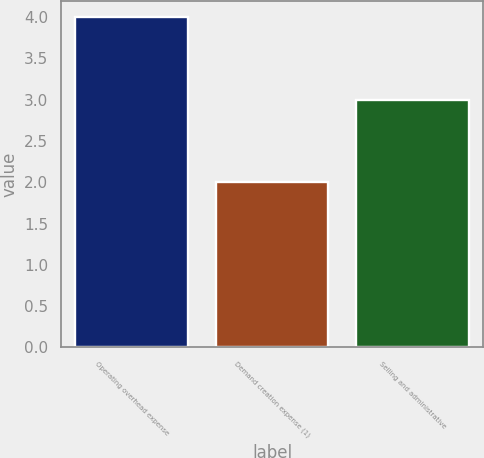Convert chart. <chart><loc_0><loc_0><loc_500><loc_500><bar_chart><fcel>Operating overhead expense<fcel>Demand creation expense (1)<fcel>Selling and administrative<nl><fcel>4<fcel>2<fcel>3<nl></chart> 